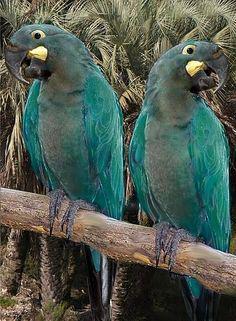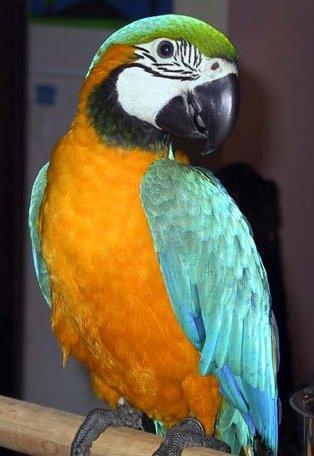The first image is the image on the left, the second image is the image on the right. Considering the images on both sides, is "There are exactly two birds in the image on the right." valid? Answer yes or no. No. 